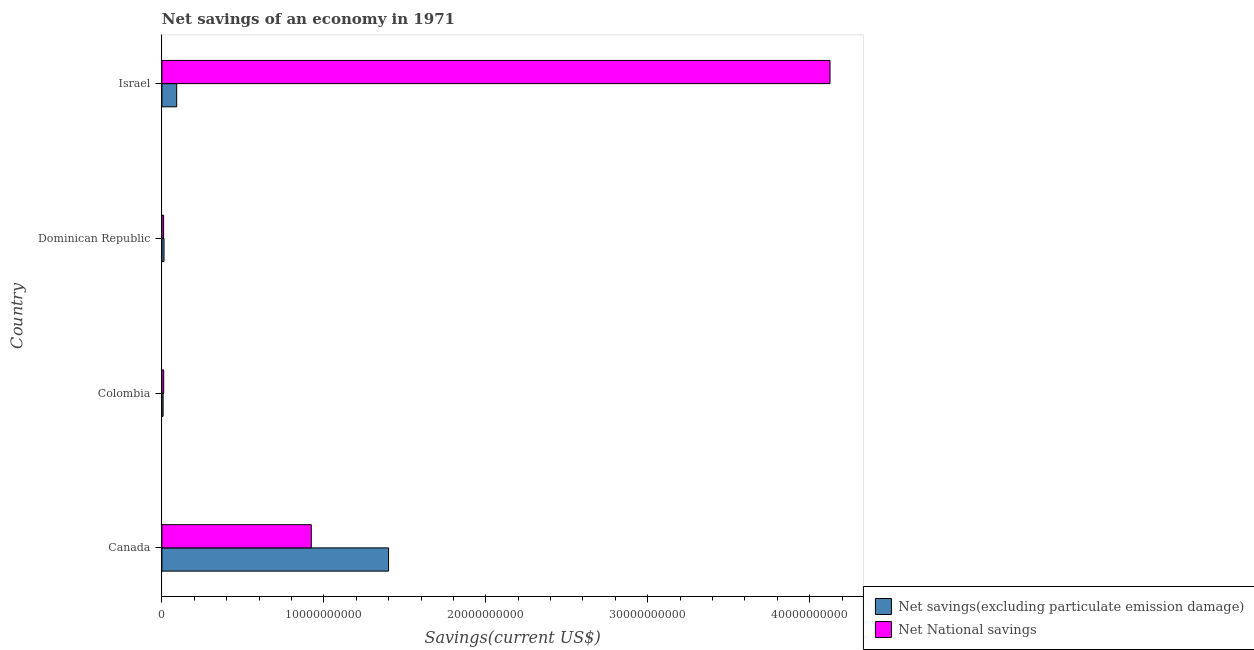What is the label of the 3rd group of bars from the top?
Your answer should be very brief. Colombia. What is the net national savings in Canada?
Offer a very short reply. 9.23e+09. Across all countries, what is the maximum net savings(excluding particulate emission damage)?
Ensure brevity in your answer.  1.40e+1. Across all countries, what is the minimum net national savings?
Offer a very short reply. 1.05e+08. In which country was the net savings(excluding particulate emission damage) maximum?
Your answer should be compact. Canada. In which country was the net savings(excluding particulate emission damage) minimum?
Make the answer very short. Colombia. What is the total net national savings in the graph?
Offer a terse response. 5.07e+1. What is the difference between the net savings(excluding particulate emission damage) in Colombia and that in Dominican Republic?
Your answer should be very brief. -5.69e+07. What is the difference between the net national savings in Dominican Republic and the net savings(excluding particulate emission damage) in Israel?
Keep it short and to the point. -8.09e+08. What is the average net savings(excluding particulate emission damage) per country?
Ensure brevity in your answer.  3.78e+09. What is the difference between the net savings(excluding particulate emission damage) and net national savings in Dominican Republic?
Your response must be concise. 2.61e+07. What is the ratio of the net national savings in Canada to that in Dominican Republic?
Your answer should be very brief. 87.52. Is the difference between the net savings(excluding particulate emission damage) in Canada and Israel greater than the difference between the net national savings in Canada and Israel?
Offer a very short reply. Yes. What is the difference between the highest and the second highest net savings(excluding particulate emission damage)?
Provide a succinct answer. 1.31e+1. What is the difference between the highest and the lowest net national savings?
Your answer should be very brief. 4.11e+1. What does the 1st bar from the top in Colombia represents?
Keep it short and to the point. Net National savings. What does the 1st bar from the bottom in Israel represents?
Make the answer very short. Net savings(excluding particulate emission damage). How many bars are there?
Offer a terse response. 8. Are all the bars in the graph horizontal?
Give a very brief answer. Yes. What is the difference between two consecutive major ticks on the X-axis?
Make the answer very short. 1.00e+1. Are the values on the major ticks of X-axis written in scientific E-notation?
Your answer should be compact. No. Does the graph contain any zero values?
Make the answer very short. No. Where does the legend appear in the graph?
Provide a short and direct response. Bottom right. What is the title of the graph?
Ensure brevity in your answer.  Net savings of an economy in 1971. What is the label or title of the X-axis?
Provide a succinct answer. Savings(current US$). What is the label or title of the Y-axis?
Make the answer very short. Country. What is the Savings(current US$) of Net savings(excluding particulate emission damage) in Canada?
Provide a short and direct response. 1.40e+1. What is the Savings(current US$) of Net National savings in Canada?
Offer a very short reply. 9.23e+09. What is the Savings(current US$) of Net savings(excluding particulate emission damage) in Colombia?
Offer a terse response. 7.46e+07. What is the Savings(current US$) in Net National savings in Colombia?
Make the answer very short. 1.11e+08. What is the Savings(current US$) of Net savings(excluding particulate emission damage) in Dominican Republic?
Offer a terse response. 1.32e+08. What is the Savings(current US$) in Net National savings in Dominican Republic?
Provide a succinct answer. 1.05e+08. What is the Savings(current US$) of Net savings(excluding particulate emission damage) in Israel?
Offer a terse response. 9.14e+08. What is the Savings(current US$) of Net National savings in Israel?
Provide a short and direct response. 4.13e+1. Across all countries, what is the maximum Savings(current US$) in Net savings(excluding particulate emission damage)?
Provide a short and direct response. 1.40e+1. Across all countries, what is the maximum Savings(current US$) in Net National savings?
Give a very brief answer. 4.13e+1. Across all countries, what is the minimum Savings(current US$) in Net savings(excluding particulate emission damage)?
Provide a succinct answer. 7.46e+07. Across all countries, what is the minimum Savings(current US$) in Net National savings?
Provide a short and direct response. 1.05e+08. What is the total Savings(current US$) of Net savings(excluding particulate emission damage) in the graph?
Your answer should be very brief. 1.51e+1. What is the total Savings(current US$) in Net National savings in the graph?
Your answer should be compact. 5.07e+1. What is the difference between the Savings(current US$) in Net savings(excluding particulate emission damage) in Canada and that in Colombia?
Your response must be concise. 1.39e+1. What is the difference between the Savings(current US$) in Net National savings in Canada and that in Colombia?
Provide a succinct answer. 9.11e+09. What is the difference between the Savings(current US$) of Net savings(excluding particulate emission damage) in Canada and that in Dominican Republic?
Provide a succinct answer. 1.39e+1. What is the difference between the Savings(current US$) in Net National savings in Canada and that in Dominican Republic?
Your response must be concise. 9.12e+09. What is the difference between the Savings(current US$) in Net savings(excluding particulate emission damage) in Canada and that in Israel?
Your answer should be compact. 1.31e+1. What is the difference between the Savings(current US$) of Net National savings in Canada and that in Israel?
Your response must be concise. -3.20e+1. What is the difference between the Savings(current US$) in Net savings(excluding particulate emission damage) in Colombia and that in Dominican Republic?
Give a very brief answer. -5.69e+07. What is the difference between the Savings(current US$) in Net National savings in Colombia and that in Dominican Republic?
Provide a short and direct response. 6.03e+06. What is the difference between the Savings(current US$) in Net savings(excluding particulate emission damage) in Colombia and that in Israel?
Your answer should be compact. -8.40e+08. What is the difference between the Savings(current US$) of Net National savings in Colombia and that in Israel?
Offer a terse response. -4.11e+1. What is the difference between the Savings(current US$) in Net savings(excluding particulate emission damage) in Dominican Republic and that in Israel?
Provide a short and direct response. -7.83e+08. What is the difference between the Savings(current US$) of Net National savings in Dominican Republic and that in Israel?
Your answer should be very brief. -4.11e+1. What is the difference between the Savings(current US$) in Net savings(excluding particulate emission damage) in Canada and the Savings(current US$) in Net National savings in Colombia?
Make the answer very short. 1.39e+1. What is the difference between the Savings(current US$) of Net savings(excluding particulate emission damage) in Canada and the Savings(current US$) of Net National savings in Dominican Republic?
Your answer should be compact. 1.39e+1. What is the difference between the Savings(current US$) of Net savings(excluding particulate emission damage) in Canada and the Savings(current US$) of Net National savings in Israel?
Make the answer very short. -2.73e+1. What is the difference between the Savings(current US$) of Net savings(excluding particulate emission damage) in Colombia and the Savings(current US$) of Net National savings in Dominican Republic?
Ensure brevity in your answer.  -3.08e+07. What is the difference between the Savings(current US$) of Net savings(excluding particulate emission damage) in Colombia and the Savings(current US$) of Net National savings in Israel?
Provide a succinct answer. -4.12e+1. What is the difference between the Savings(current US$) in Net savings(excluding particulate emission damage) in Dominican Republic and the Savings(current US$) in Net National savings in Israel?
Keep it short and to the point. -4.11e+1. What is the average Savings(current US$) in Net savings(excluding particulate emission damage) per country?
Offer a very short reply. 3.78e+09. What is the average Savings(current US$) in Net National savings per country?
Make the answer very short. 1.27e+1. What is the difference between the Savings(current US$) in Net savings(excluding particulate emission damage) and Savings(current US$) in Net National savings in Canada?
Ensure brevity in your answer.  4.77e+09. What is the difference between the Savings(current US$) of Net savings(excluding particulate emission damage) and Savings(current US$) of Net National savings in Colombia?
Give a very brief answer. -3.68e+07. What is the difference between the Savings(current US$) of Net savings(excluding particulate emission damage) and Savings(current US$) of Net National savings in Dominican Republic?
Keep it short and to the point. 2.61e+07. What is the difference between the Savings(current US$) in Net savings(excluding particulate emission damage) and Savings(current US$) in Net National savings in Israel?
Your response must be concise. -4.03e+1. What is the ratio of the Savings(current US$) in Net savings(excluding particulate emission damage) in Canada to that in Colombia?
Offer a terse response. 187.59. What is the ratio of the Savings(current US$) in Net National savings in Canada to that in Colombia?
Offer a terse response. 82.79. What is the ratio of the Savings(current US$) in Net savings(excluding particulate emission damage) in Canada to that in Dominican Republic?
Offer a terse response. 106.4. What is the ratio of the Savings(current US$) of Net National savings in Canada to that in Dominican Republic?
Make the answer very short. 87.52. What is the ratio of the Savings(current US$) in Net savings(excluding particulate emission damage) in Canada to that in Israel?
Provide a succinct answer. 15.31. What is the ratio of the Savings(current US$) in Net National savings in Canada to that in Israel?
Offer a very short reply. 0.22. What is the ratio of the Savings(current US$) of Net savings(excluding particulate emission damage) in Colombia to that in Dominican Republic?
Provide a short and direct response. 0.57. What is the ratio of the Savings(current US$) in Net National savings in Colombia to that in Dominican Republic?
Provide a short and direct response. 1.06. What is the ratio of the Savings(current US$) in Net savings(excluding particulate emission damage) in Colombia to that in Israel?
Your response must be concise. 0.08. What is the ratio of the Savings(current US$) in Net National savings in Colombia to that in Israel?
Provide a short and direct response. 0. What is the ratio of the Savings(current US$) in Net savings(excluding particulate emission damage) in Dominican Republic to that in Israel?
Ensure brevity in your answer.  0.14. What is the ratio of the Savings(current US$) of Net National savings in Dominican Republic to that in Israel?
Your response must be concise. 0. What is the difference between the highest and the second highest Savings(current US$) in Net savings(excluding particulate emission damage)?
Your answer should be compact. 1.31e+1. What is the difference between the highest and the second highest Savings(current US$) in Net National savings?
Offer a terse response. 3.20e+1. What is the difference between the highest and the lowest Savings(current US$) in Net savings(excluding particulate emission damage)?
Provide a short and direct response. 1.39e+1. What is the difference between the highest and the lowest Savings(current US$) in Net National savings?
Give a very brief answer. 4.11e+1. 